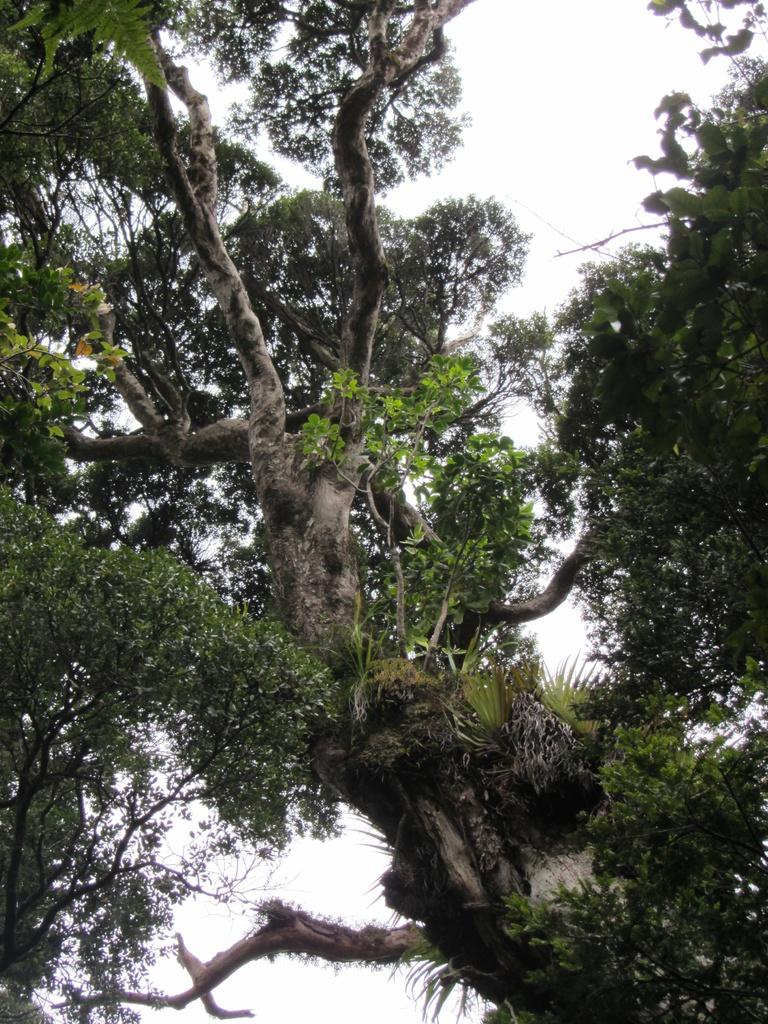What type of vegetation is present in the image? There are trees with branches in the image. What can be found on the trees? There are leaves on the trees. What is the condition of the sky in the image? The sky is clear in the image. What type of waste can be seen on the ground in the image? There is no waste present on the ground in the image; it only features trees with branches and leaves. What time of day is it in the image, considering the presence of afternoon light? The provided facts do not mention the time of day or any specific light source, so it cannot be determined from the image. 